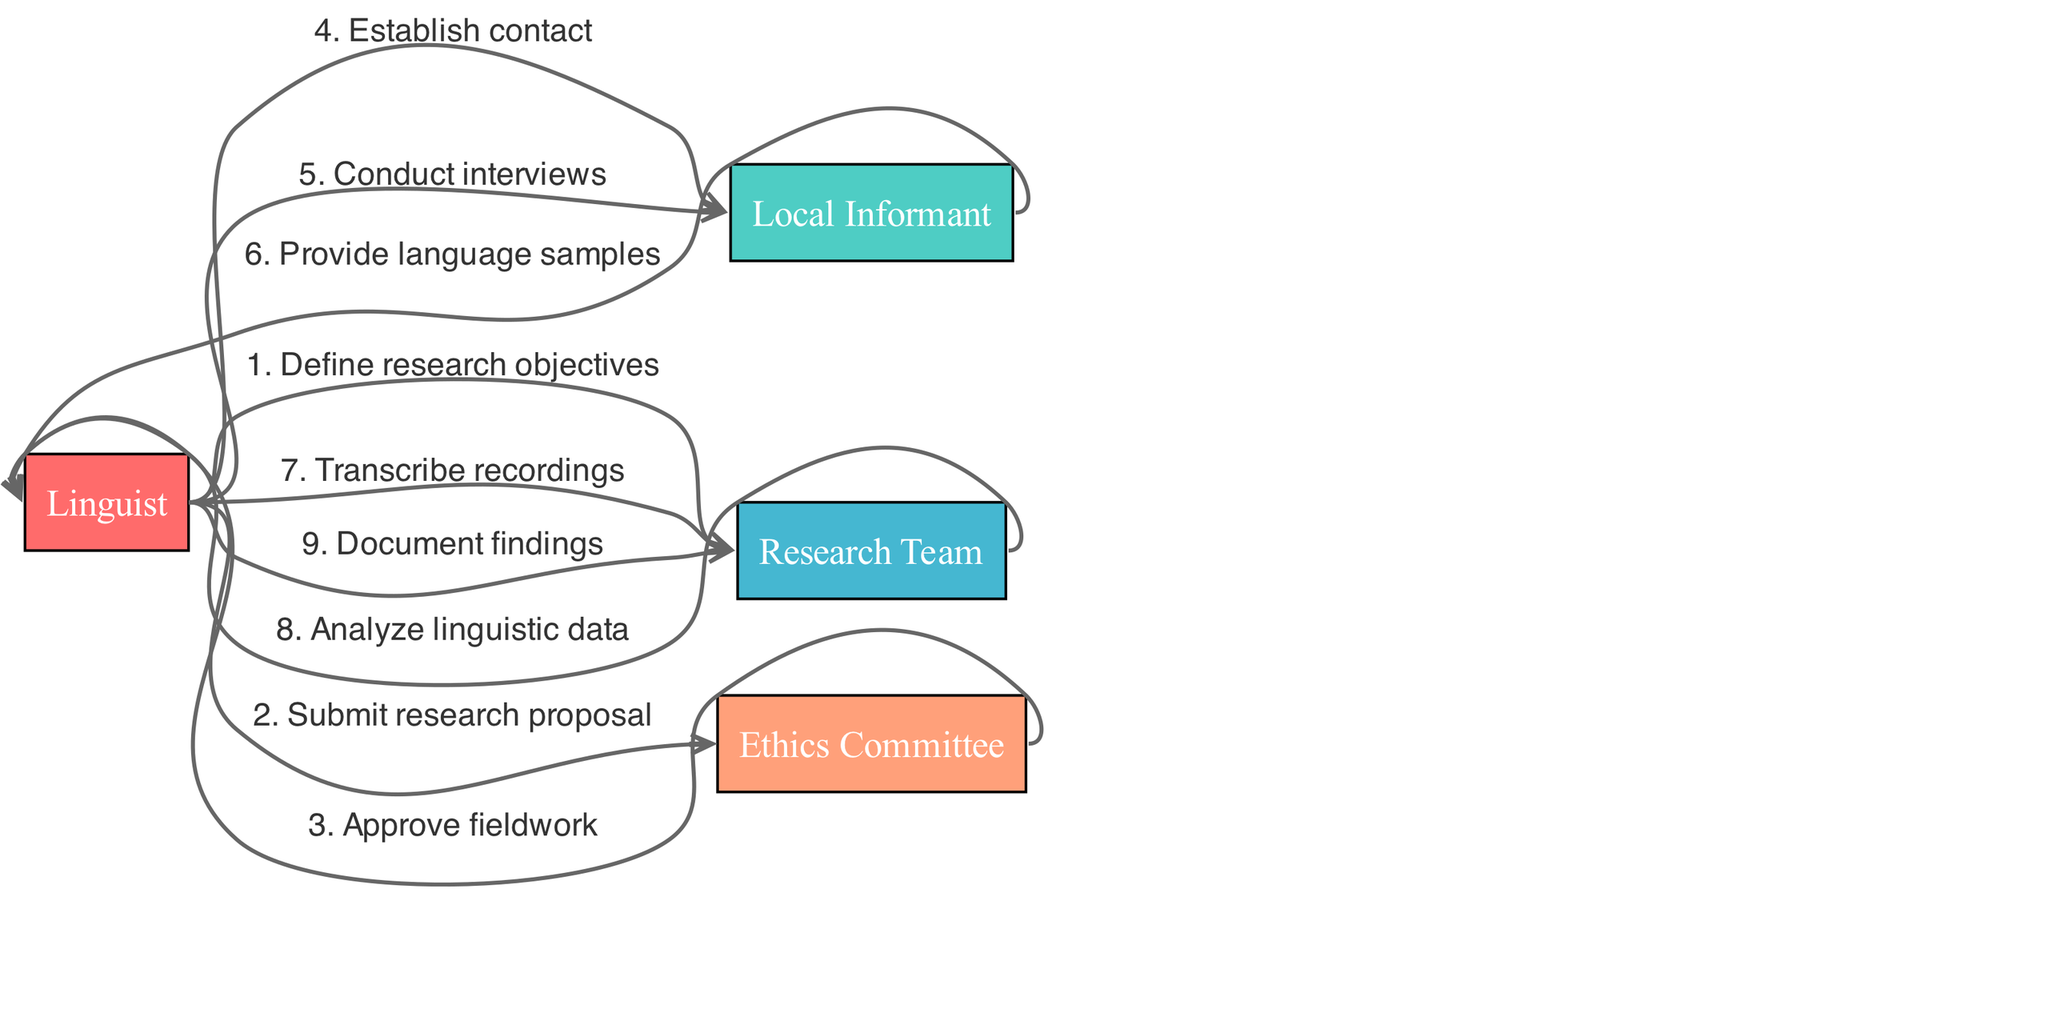What is the first action in the sequence? The first action in the sequence is identified by looking at the diagram starting from the Linguist, who communicates with the Research Team to define research objectives.
Answer: Define research objectives Which actor is responsible for analyzing linguistic data? To find the actor responsible for analyzing linguistic data, I trace the flow from the Research Team in the sequence where they receive data from the Linguist before conducting their analysis.
Answer: Research Team How many actors are involved in this sequence? The number of actors can be counted from the list at the top of the diagram, which includes four distinct actors.
Answer: Four What is the last action performed in the sequence? The last action is determined by looking at the sequence of actions, where the last item shows the Linguist documenting findings.
Answer: Document findings Who must approve the fieldwork before it can be conducted? The action sequence indicates that the Ethics Committee is responsible for approving the fieldwork before it can proceed, as shown in the interaction following the submission of the research proposal.
Answer: Ethics Committee How many actions are performed by the Linguist during the fieldwork? By reviewing the sequence, I can count the number of actions that the Linguist takes; there are four actions performed by the Linguist throughout the process.
Answer: Four Which actor provides language samples to the Linguist? The Local Informant is indicated in the sequence as the actor who provides the language samples to the Linguist following their interviews.
Answer: Local Informant What step follows the submission of the research proposal? After the Linguist submits the research proposal to the Ethics Committee, the next step in the sequence is the approval of the fieldwork.
Answer: Approve fieldwork At which step does the Linguist establish contact with the Local Informant? The step where the Linguist establishes contact with the Local Informant can be found directly after the approval of the fieldwork in the sequence of interactions.
Answer: Establish contact 